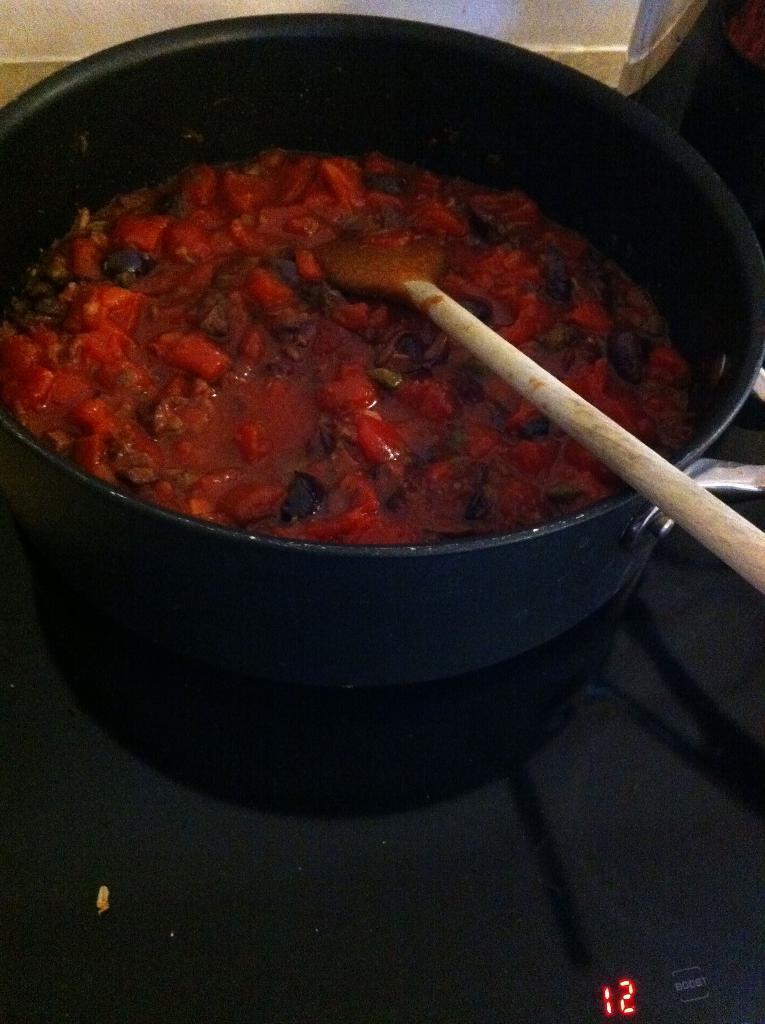Can you describe this image briefly? In this image we can see a bowl, spatula, and food on a platform. At the bottom we can see digital numbers. 